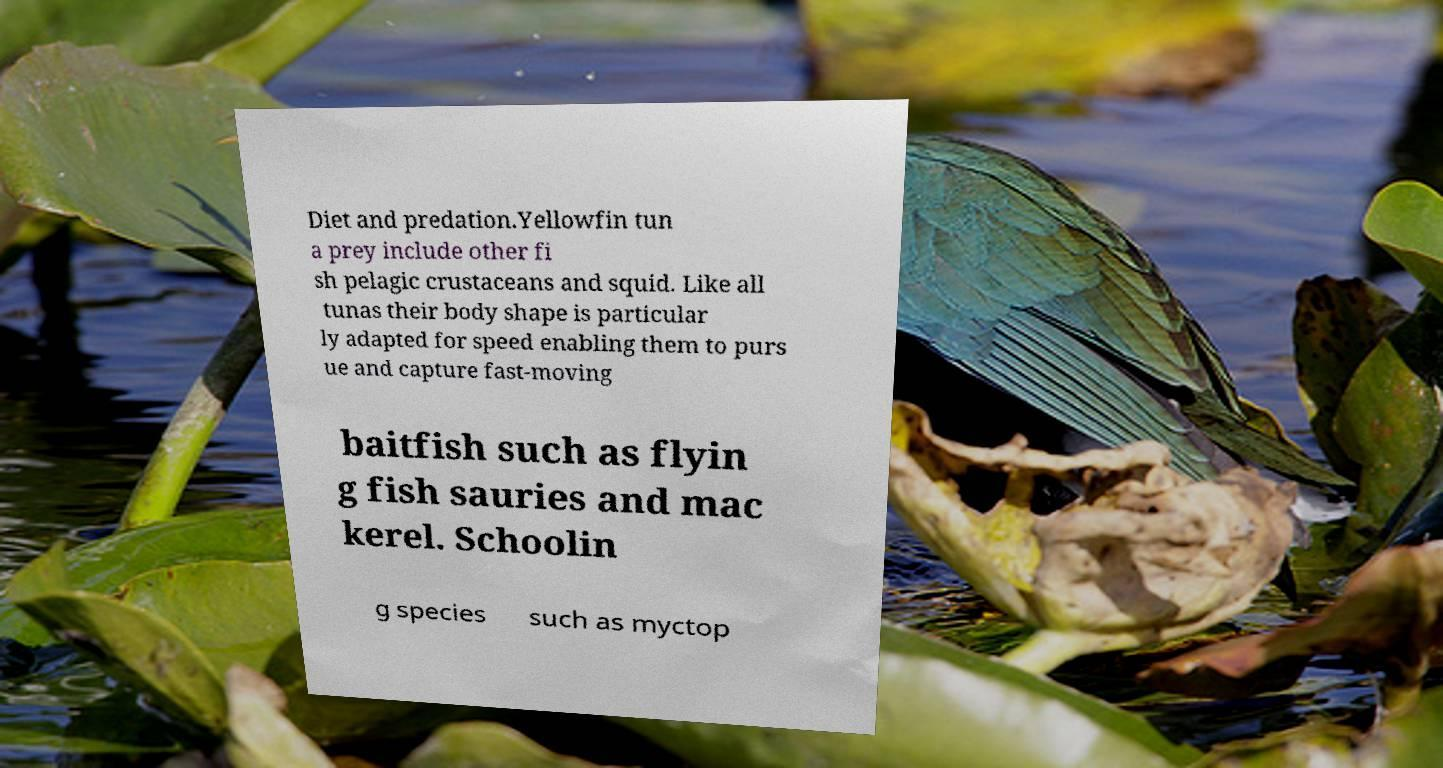Please read and relay the text visible in this image. What does it say? Diet and predation.Yellowfin tun a prey include other fi sh pelagic crustaceans and squid. Like all tunas their body shape is particular ly adapted for speed enabling them to purs ue and capture fast-moving baitfish such as flyin g fish sauries and mac kerel. Schoolin g species such as myctop 